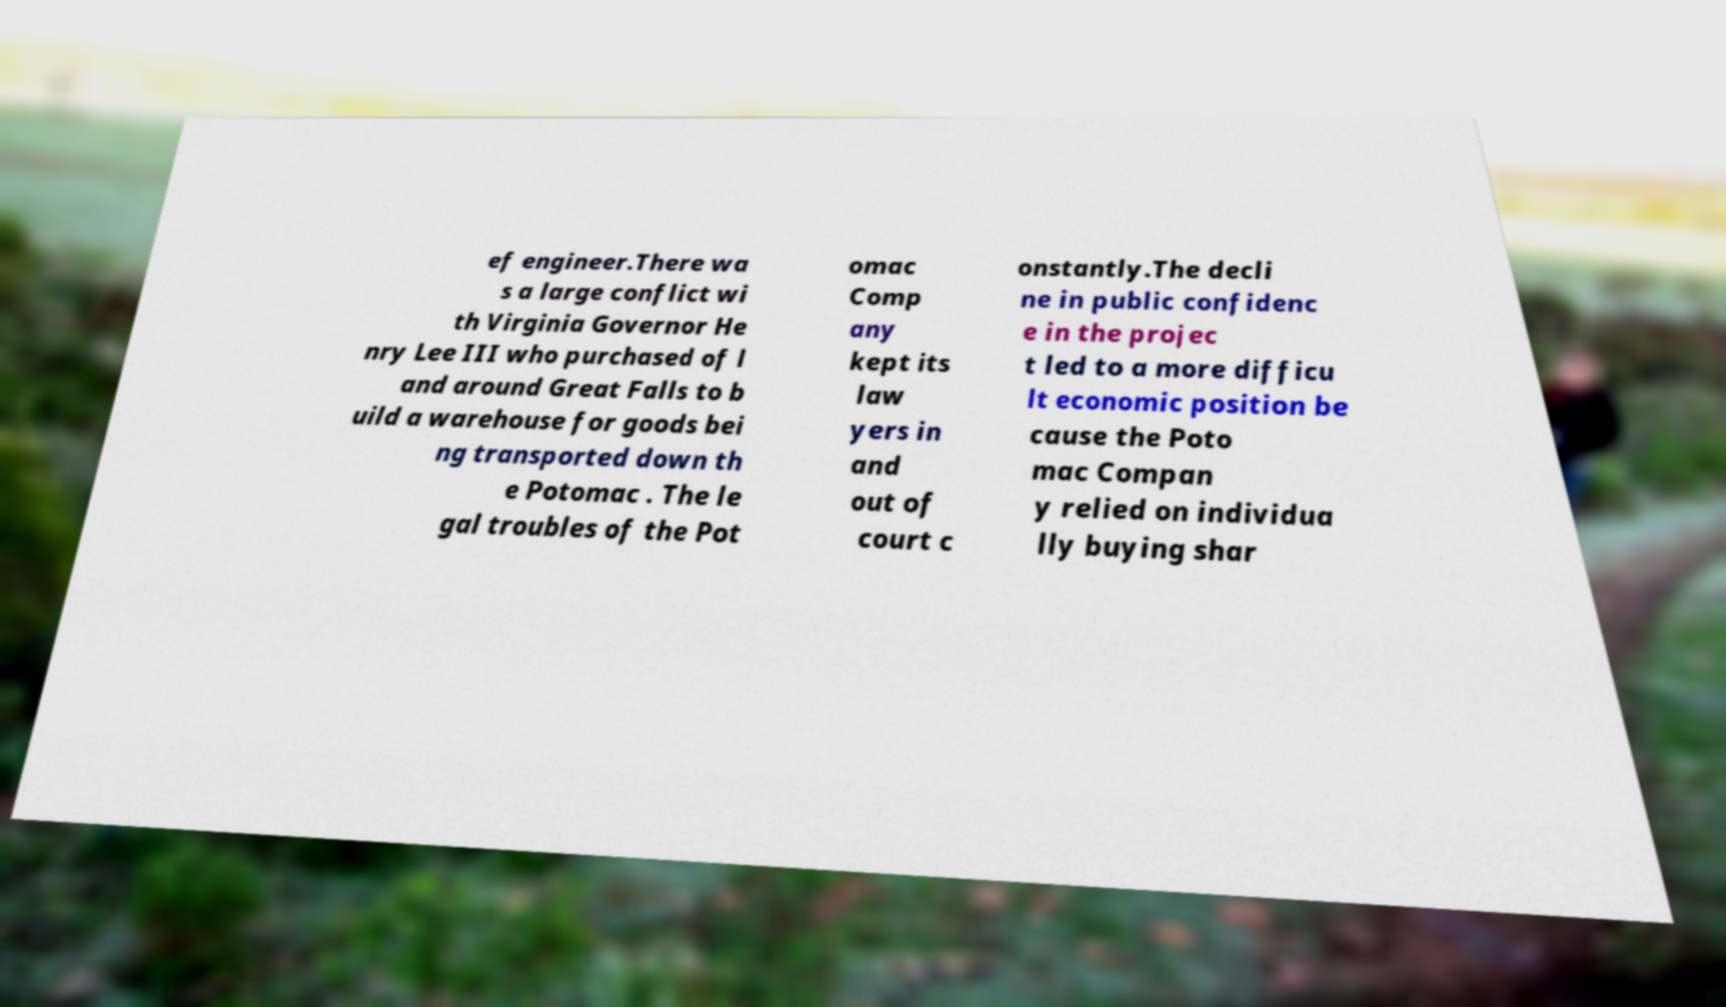For documentation purposes, I need the text within this image transcribed. Could you provide that? ef engineer.There wa s a large conflict wi th Virginia Governor He nry Lee III who purchased of l and around Great Falls to b uild a warehouse for goods bei ng transported down th e Potomac . The le gal troubles of the Pot omac Comp any kept its law yers in and out of court c onstantly.The decli ne in public confidenc e in the projec t led to a more difficu lt economic position be cause the Poto mac Compan y relied on individua lly buying shar 